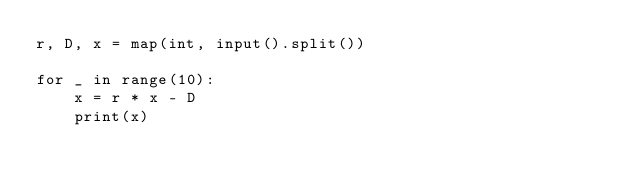Convert code to text. <code><loc_0><loc_0><loc_500><loc_500><_Python_>r, D, x = map(int, input().split())

for _ in range(10):
    x = r * x - D
    print(x)
</code> 